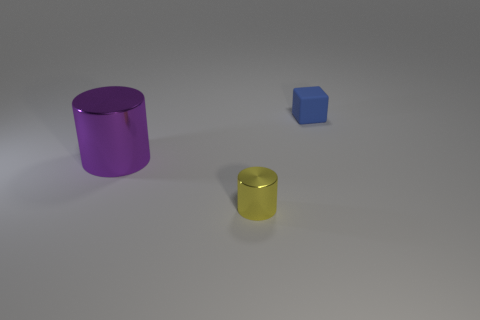Add 2 small yellow metallic cylinders. How many objects exist? 5 Subtract all blocks. How many objects are left? 2 Add 1 blue things. How many blue things are left? 2 Add 2 tiny cylinders. How many tiny cylinders exist? 3 Subtract 0 purple cubes. How many objects are left? 3 Subtract all blue things. Subtract all metal cylinders. How many objects are left? 0 